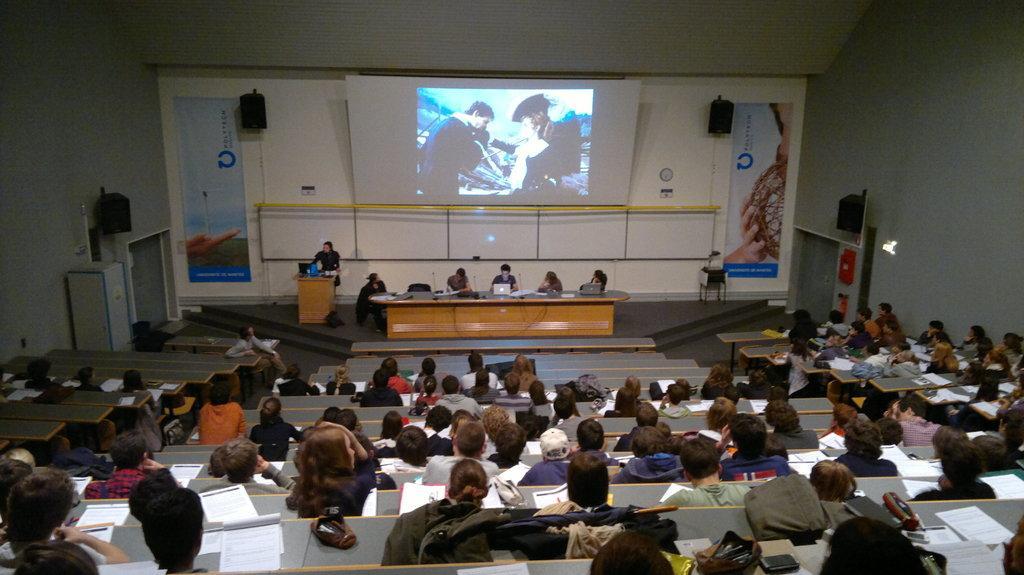Can you describe this image briefly? In this image there are group of persons, there are persons truncated towards the bottom of the image, there are benches, there are objects on the benches, there are persons truncated towards the right of the image, there are objects truncated towards the left of the image, there is a desk, there are objects on the desk, there is a person standing, there is a podium, there are objects on the podium, there are objects on the ground, there is a screen, there is a wall truncated towards the top of the image, there are objects on the wall, there is text on the banners. 